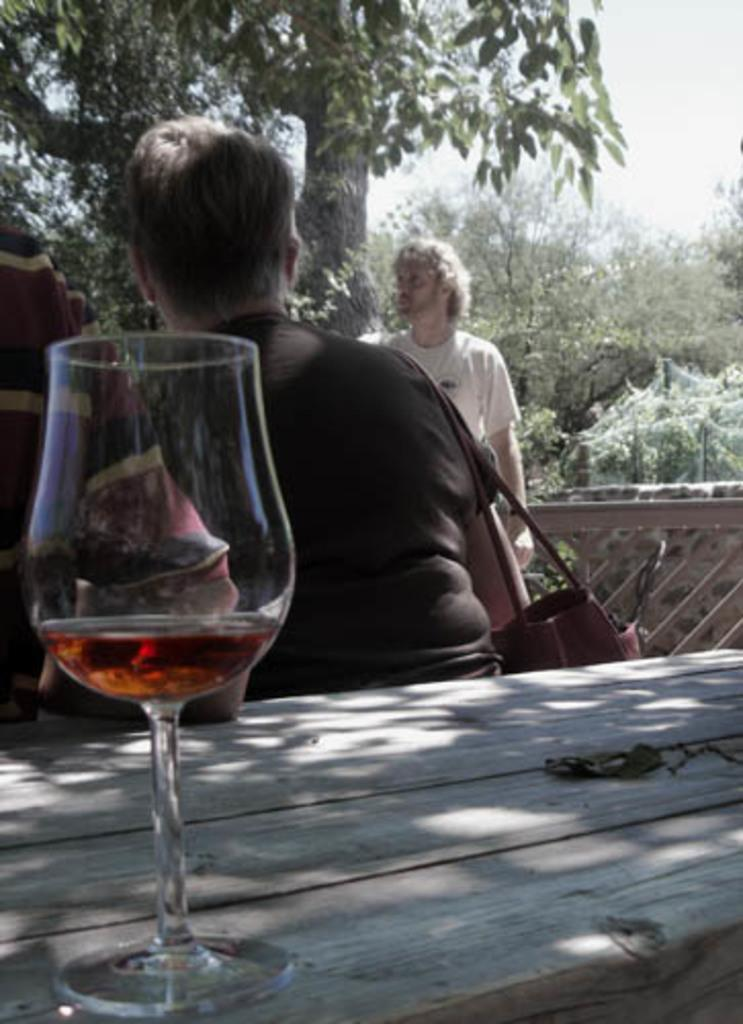What object is on the table in the image? There is a glass on the table in the image. How many people are present in the image? There are two persons in the image. What is one person doing in the image? One person is carrying a bag. What can be seen in the background of the image? There are trees and the sky visible in the background of the image. What is the opinion of the shelf on the mass of the glass in the image? There is no shelf or mass mentioned in the image, and therefore no such opinion can be determined. 